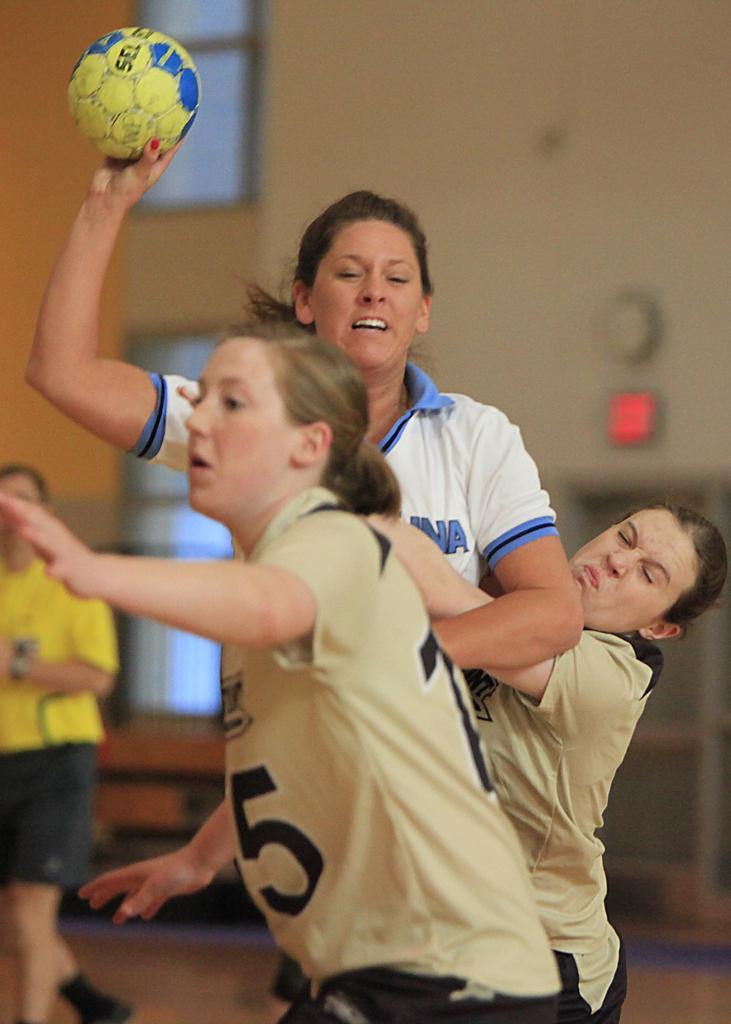Please provide a concise description of this image. This image is clicked in a ground where women are playing something with a ball two women are wearing mustard color t-shirts and one woman is wearing white color t-shirt. she is in the middle of the image is holding a yellow color ball and in the left side corner there is a woman who is wearing yellow colour t-shirt and black short, backside of a there is a window. 